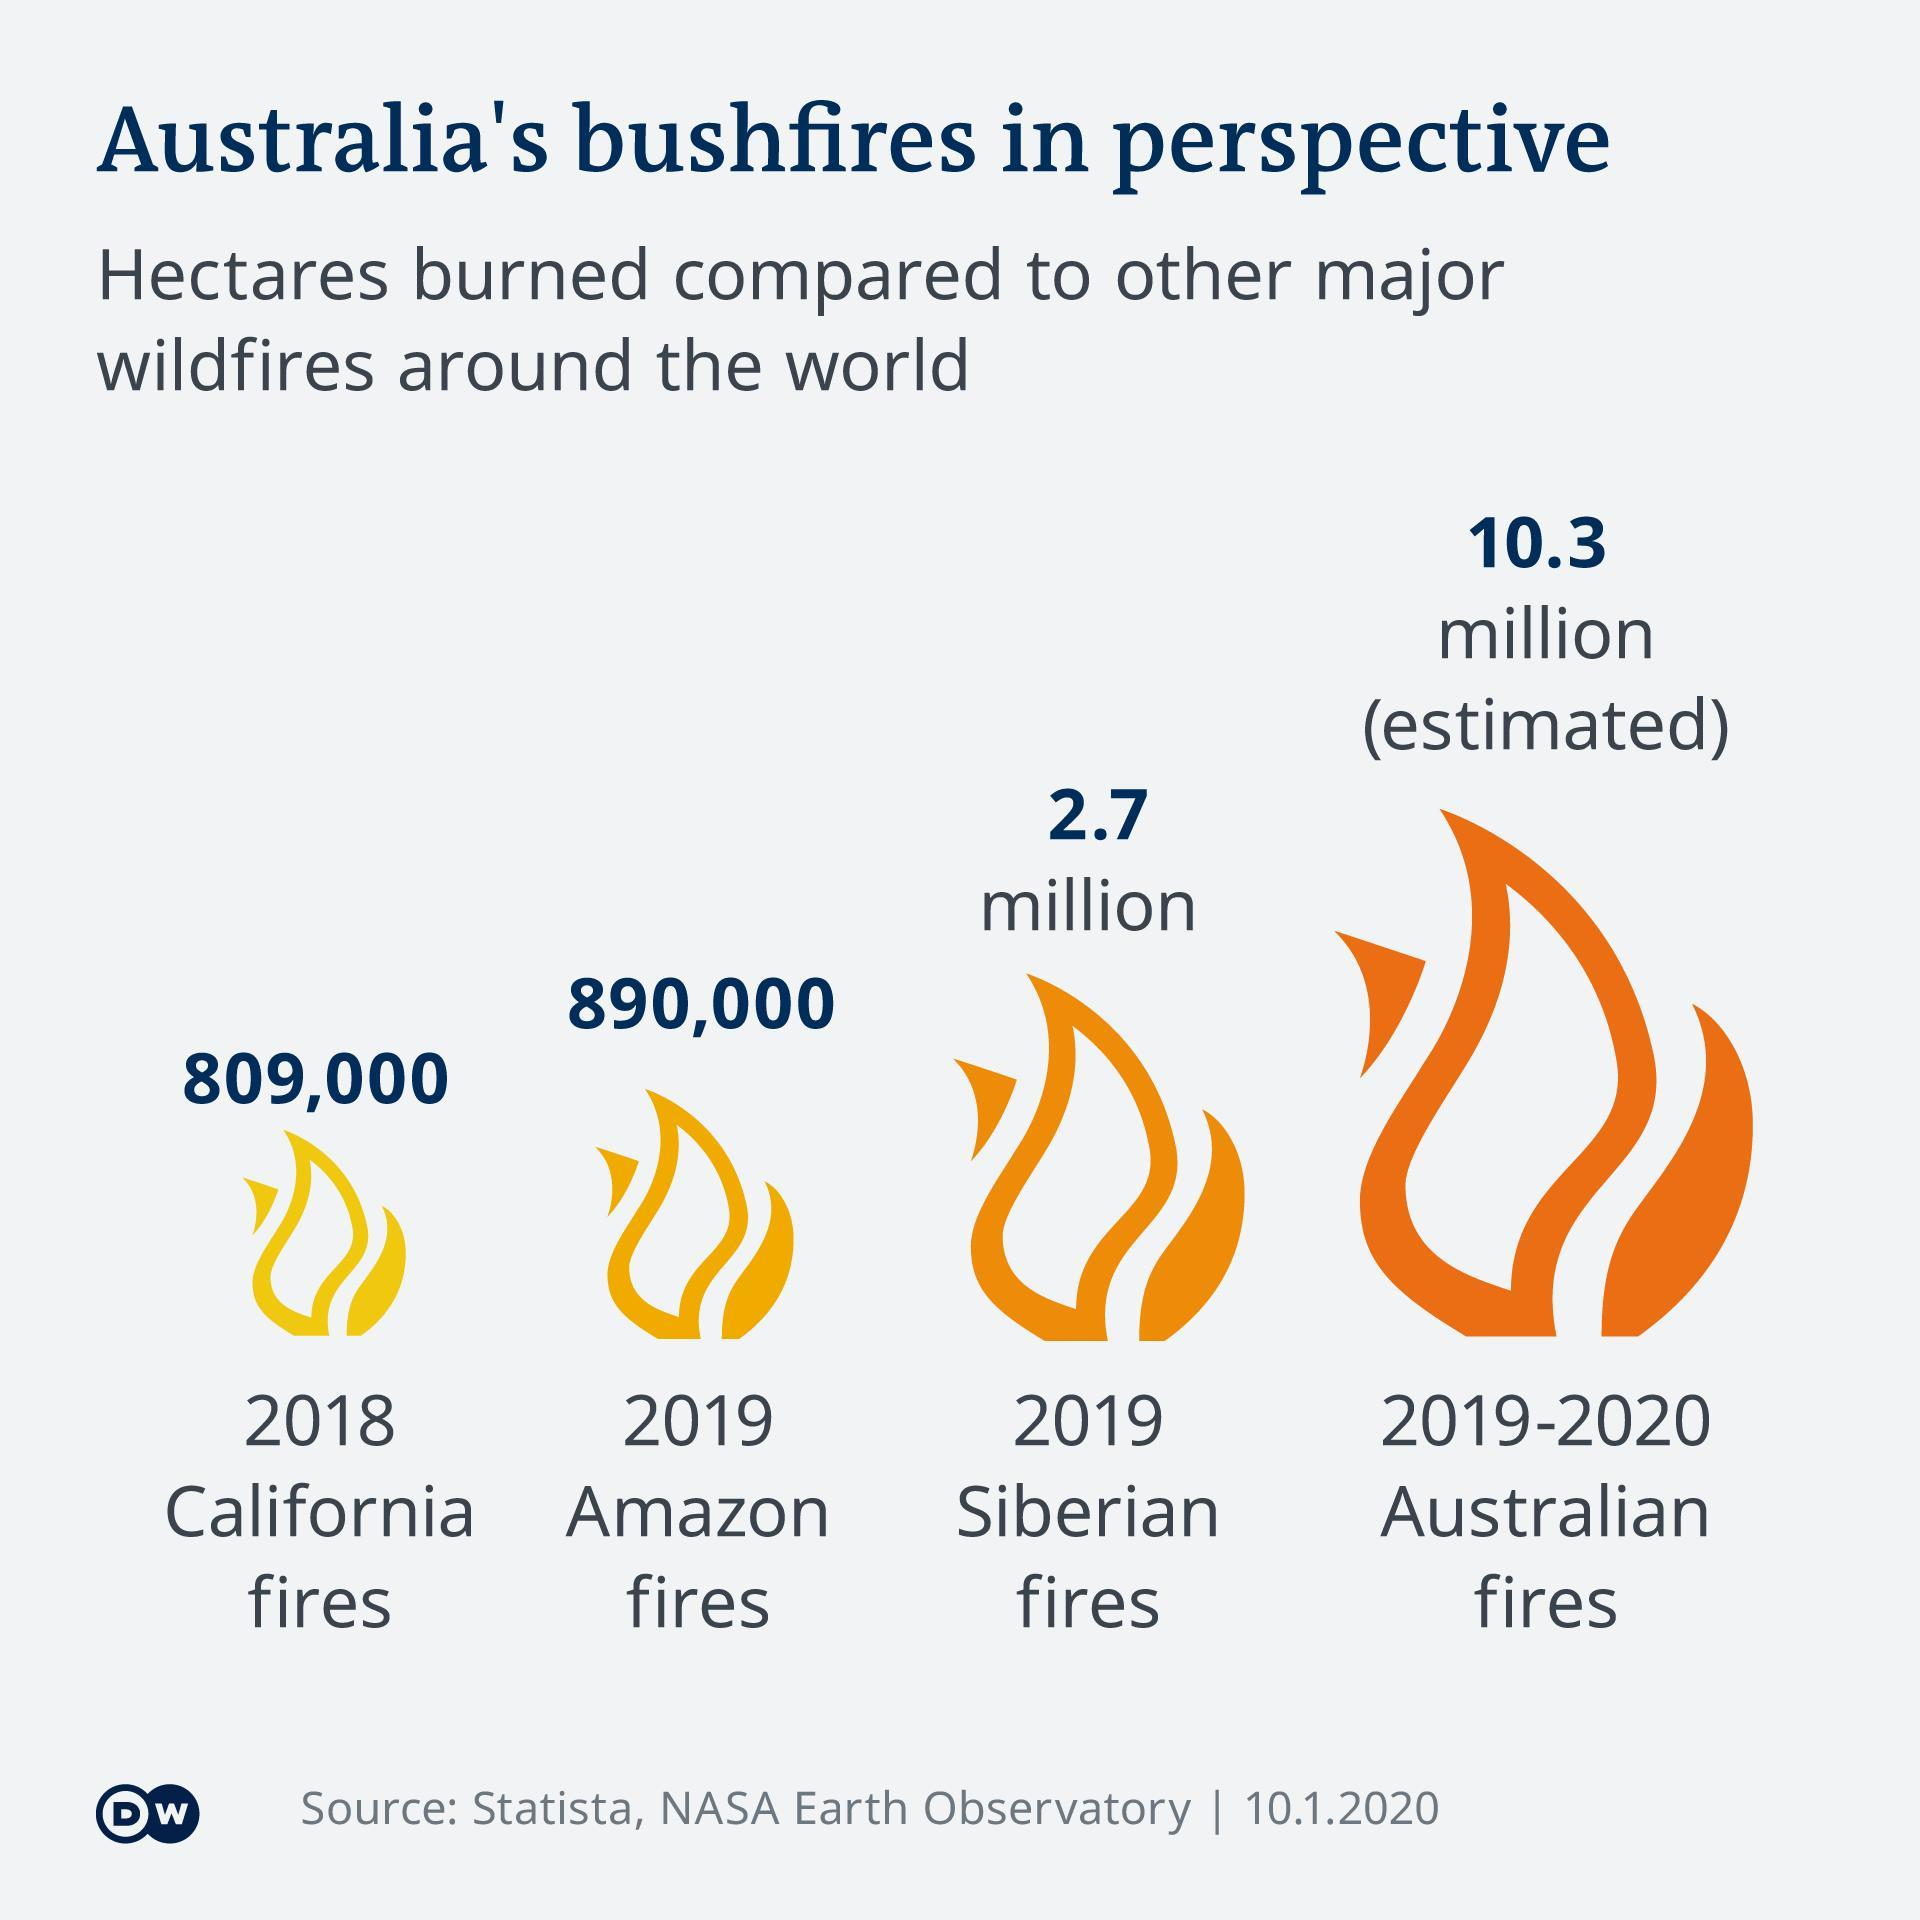How many hectares of land got burned in the 2019 Siberian Fires?
Answer the question with a short phrase. 2.7 Million How many hectares of land got burned in the 2019-2020 Australian Fires? 10.3 Million How many hectares of land got burned in the 2018 California Fires? 809,000 How many hectares of land got burned in the 2019 Amazon Fires? 890,000 